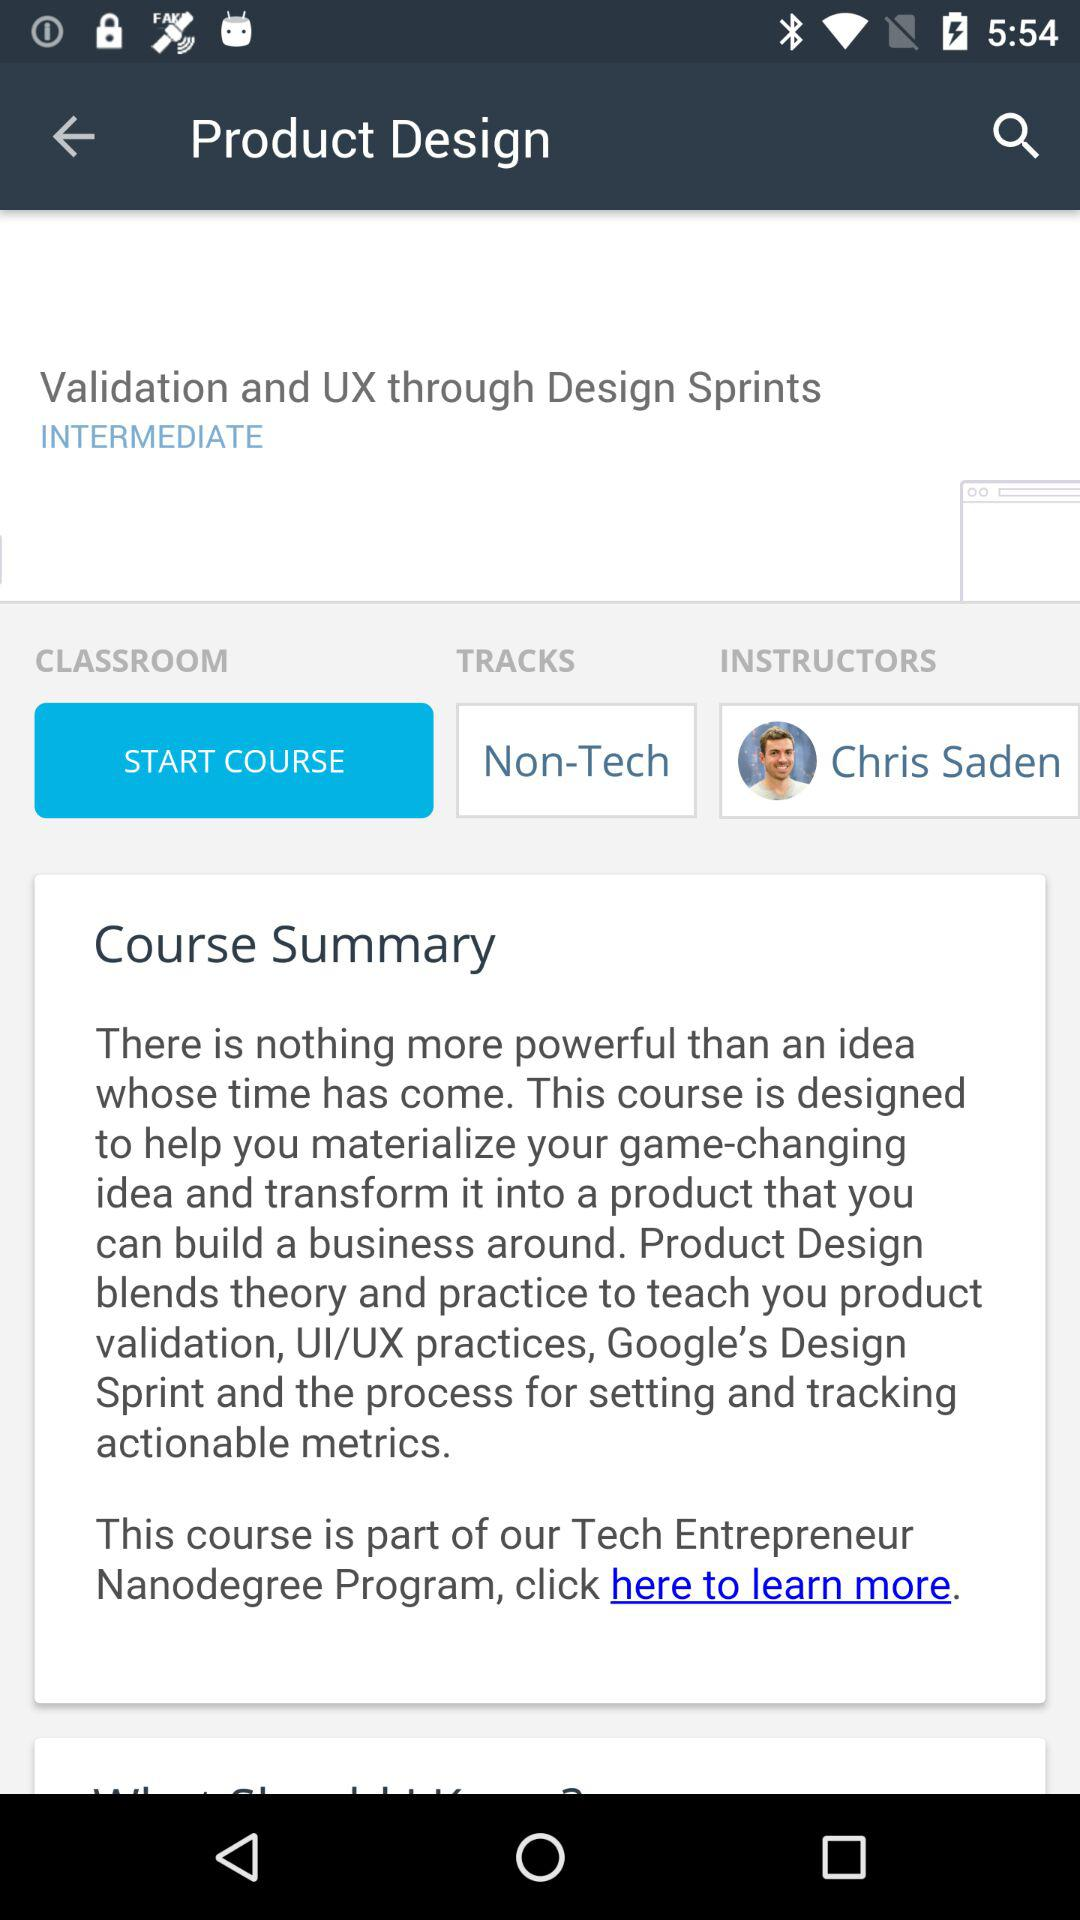Who is the instructor? The instructor is Chris Saden. 